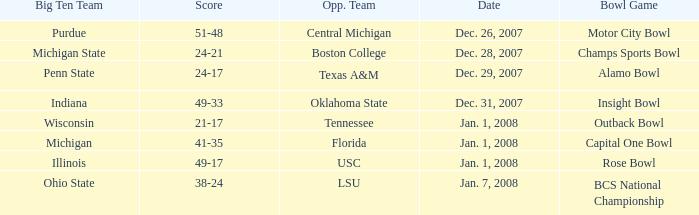Who was the rival team in the game that ended with a 21-17 score? Tennessee. Parse the table in full. {'header': ['Big Ten Team', 'Score', 'Opp. Team', 'Date', 'Bowl Game'], 'rows': [['Purdue', '51-48', 'Central Michigan', 'Dec. 26, 2007', 'Motor City Bowl'], ['Michigan State', '24-21', 'Boston College', 'Dec. 28, 2007', 'Champs Sports Bowl'], ['Penn State', '24-17', 'Texas A&M', 'Dec. 29, 2007', 'Alamo Bowl'], ['Indiana', '49-33', 'Oklahoma State', 'Dec. 31, 2007', 'Insight Bowl'], ['Wisconsin', '21-17', 'Tennessee', 'Jan. 1, 2008', 'Outback Bowl'], ['Michigan', '41-35', 'Florida', 'Jan. 1, 2008', 'Capital One Bowl'], ['Illinois', '49-17', 'USC', 'Jan. 1, 2008', 'Rose Bowl'], ['Ohio State', '38-24', 'LSU', 'Jan. 7, 2008', 'BCS National Championship']]} 